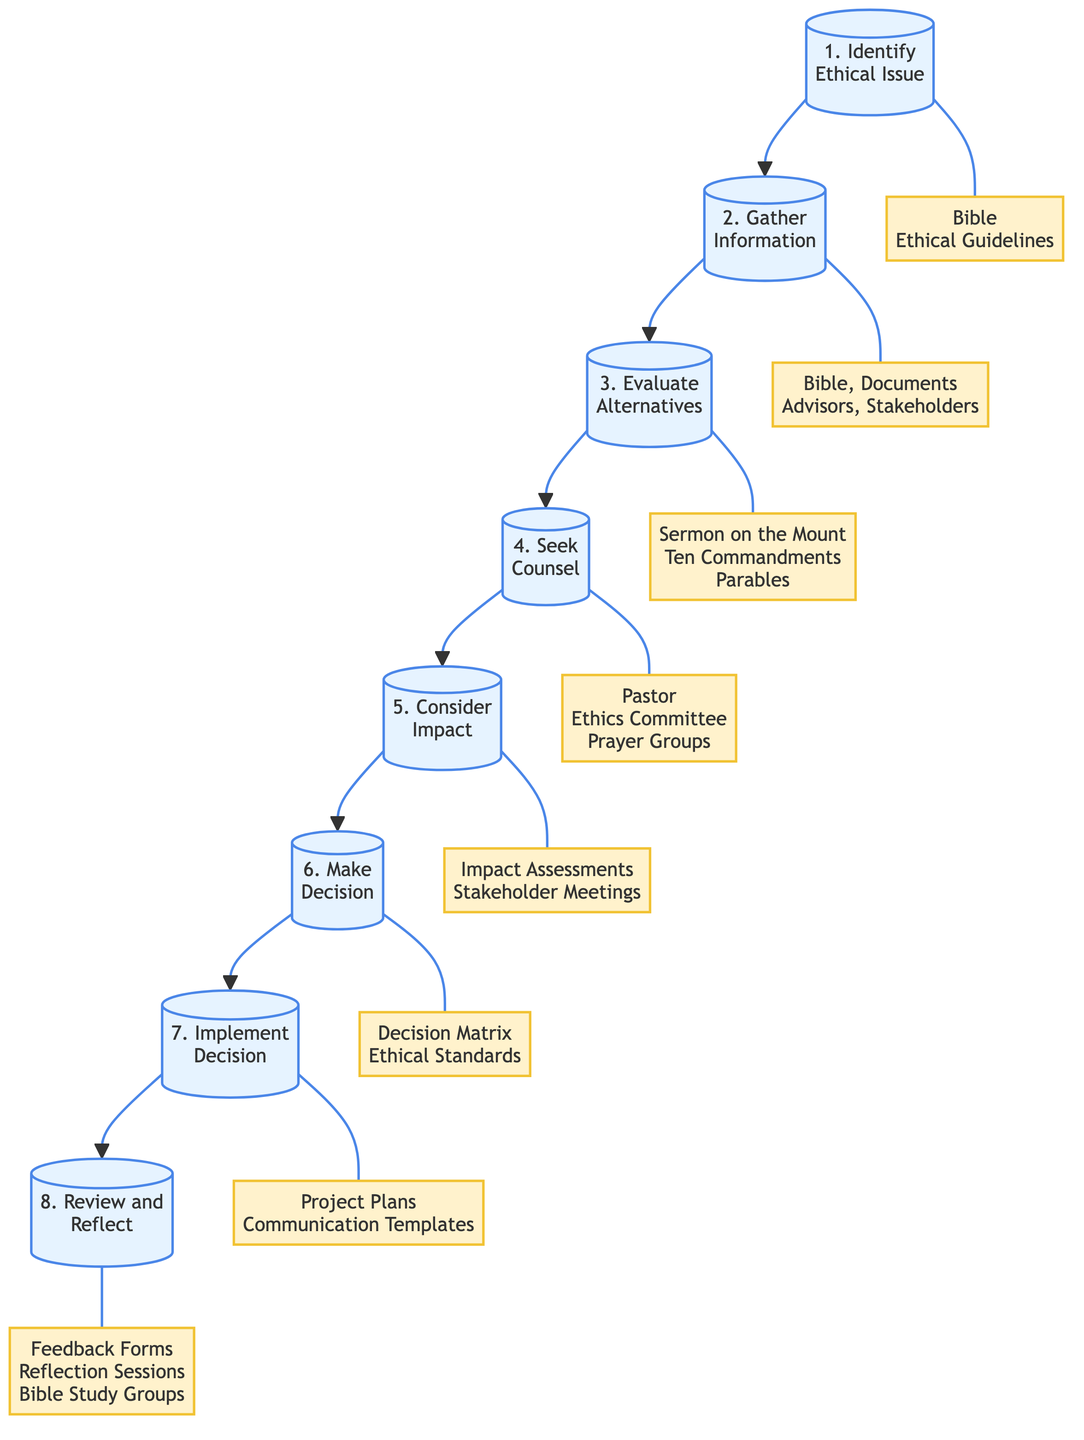What is the first step in the flow chart? The first step is represented at the top of the flow chart as "Identify Ethical Issue". This step sets the foundation for the decision-making process.
Answer: Identify Ethical Issue How many total steps are there in the diagram? There are a total of eight steps in the flow chart, each leading sequentially to the next in the decision-making process.
Answer: 8 What resources are associated with the step "Gather Information"? The resources linked with this step include the "Bible, Documents, Advisors, Stakeholders". Each of these provides necessary data and perspectives for informed decision-making.
Answer: Bible, Documents, Advisors, Stakeholders Which step comes immediately after "Evaluate Alternatives"? The step that follows "Evaluate Alternatives" is "Seek Counsel". This indicates a reliance on advice from mentors and leaders after assessing different options.
Answer: Seek Counsel What is the primary focus of the step "Consider Impact"? The primary focus of "Consider Impact" is to evaluate the potential outcomes on all stakeholders with an emphasis on love and justice as per the Greatest Commandment.
Answer: Impact on all stakeholders Which two steps involve consultation with external resources? The steps that involve consulting external resources are "Gather Information" and "Seek Counsel". These steps emphasize the importance of involving advisors and mentors in the decision-making process.
Answer: Gather Information and Seek Counsel What is the last step in the decision-making flow chart? The last step in the flow chart is "Review and Reflect", which entails assessing the decision's outcomes and ensuring future alignment with Christian ethics.
Answer: Review and Reflect What does the "Implement Decision" step emphasize? The "Implement Decision" step emphasizes executing the chosen course of action with integrity and transparency, along with clear communication of the rationale.
Answer: Integrity and transparency 